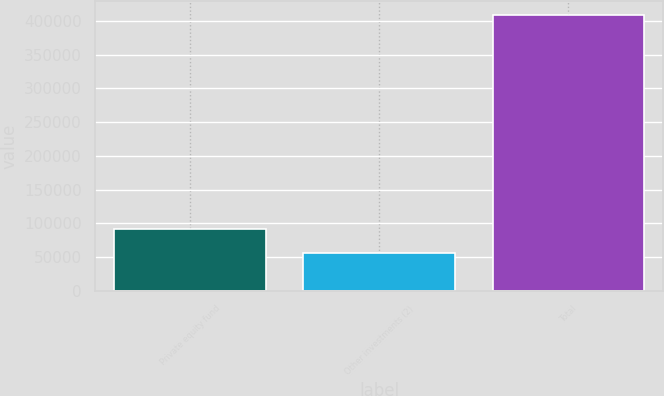Convert chart to OTSL. <chart><loc_0><loc_0><loc_500><loc_500><bar_chart><fcel>Private equity fund<fcel>Other investments (2)<fcel>Total<nl><fcel>91475.1<fcel>56242<fcel>408573<nl></chart> 